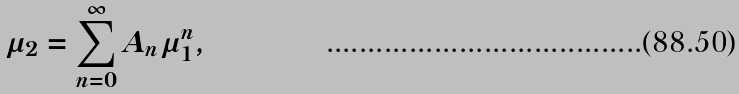Convert formula to latex. <formula><loc_0><loc_0><loc_500><loc_500>\mu _ { 2 } = \sum _ { n = 0 } ^ { \infty } A _ { n } \mu _ { 1 } ^ { n } ,</formula> 